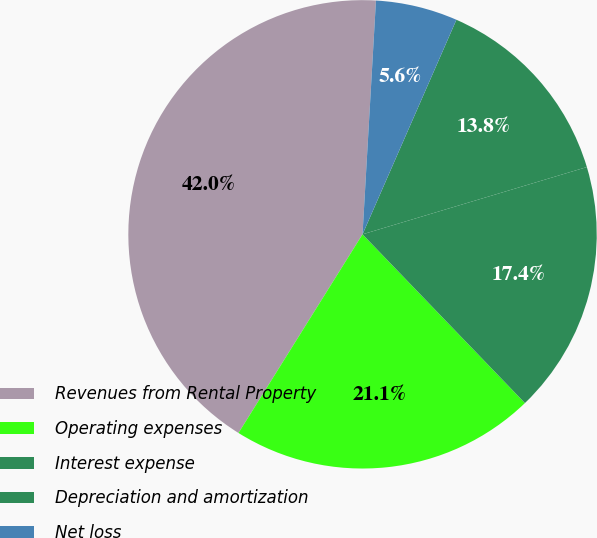<chart> <loc_0><loc_0><loc_500><loc_500><pie_chart><fcel>Revenues from Rental Property<fcel>Operating expenses<fcel>Interest expense<fcel>Depreciation and amortization<fcel>Net loss<nl><fcel>42.03%<fcel>21.08%<fcel>17.44%<fcel>13.8%<fcel>5.65%<nl></chart> 